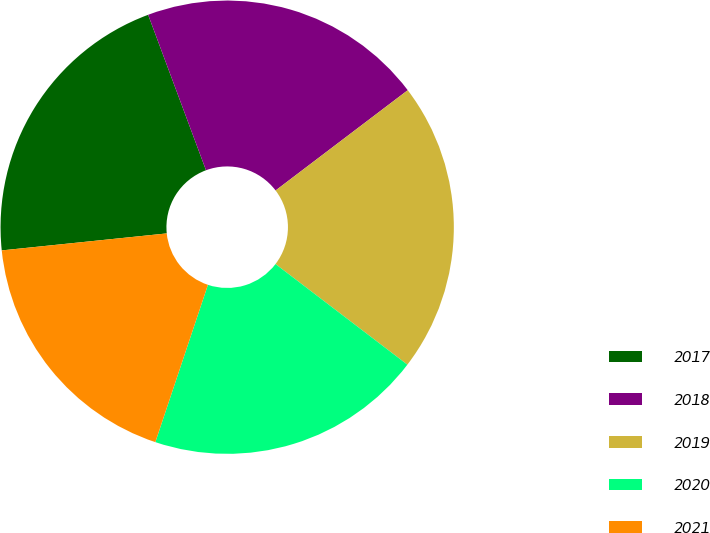Convert chart to OTSL. <chart><loc_0><loc_0><loc_500><loc_500><pie_chart><fcel>2017<fcel>2018<fcel>2019<fcel>2020<fcel>2021<nl><fcel>20.96%<fcel>20.34%<fcel>20.7%<fcel>19.76%<fcel>18.23%<nl></chart> 